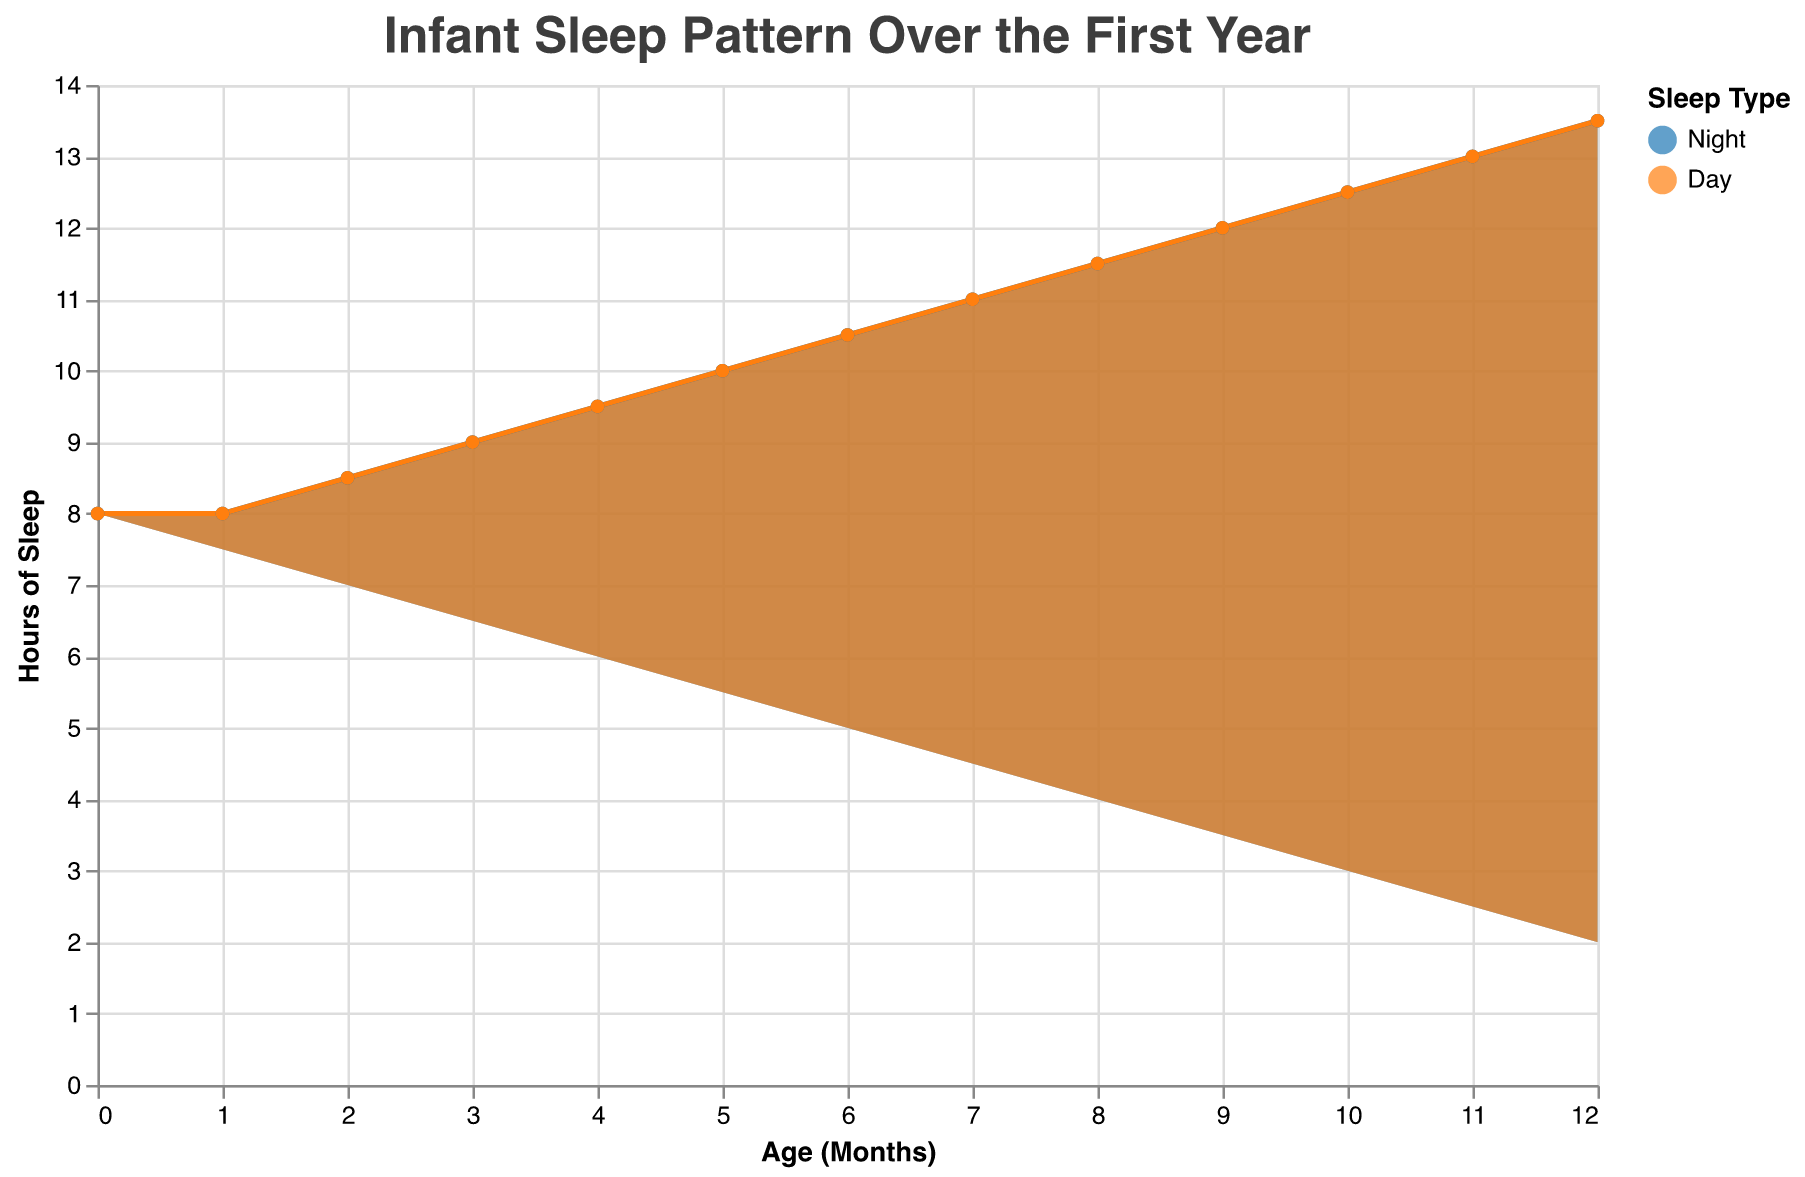What is the title of the chart? The title of the chart is typically placed at the top and is a description of the data represented in the figure. Here, it reads "Infant Sleep Pattern Over the First Year".
Answer: Infant Sleep Pattern Over the First Year How many hours of night sleep does a 6-month-old infant get? To find this information, look on the X-axis for 6 months and then follow it up to the corresponding value on the Y-axis for hours of sleep at night.
Answer: 10.5 What is the total number of hours of sleep for a 4-month-old infant? According to the data, the total hours of sleep per day across all months are constant at 15.5 hours.
Answer: 15.5 How does the amount of day sleep change from month 0 to month 12? The question requires you to look at the Hours of Sleep (Day) from Month 0 to Month 12. At month 0, it's 8 hours and it decreases incrementally to 2 hours by month 12.
Answer: Decreases from 8 to 2 hours Compare the amount of night sleep to day sleep at 9 months. Which is greater and by how much? At 9 months, the Hours of Sleep (Night) is 12 and Hours of Sleep (Day) is 3. Subtracting the day sleep from night sleep gives us the difference.
Answer: Night sleep is greater by 9 hours What trend can be observed in the night sleep pattern from month 0 to month 12? The pattern shows a gradual increase in night sleep. Starting from 8 hours at month 0, it steadily increases to 13.5 hours by month 12.
Answer: Gradual increase What is the difference in total sleep hours between month 0 and month 1? The data shows the total hours of sleep is 16 hours at month 0 and 15.5 hours at month 1. The difference is 16 - 15.5.
Answer: 0.5 hours At what month does an infant start sleeping more at night than during the day? Looking at the chart, you can observe that from month 5 onward, the night sleep hours exceed the day sleep hours.
Answer: 5 months What is the cumulative night sleep for the first 6 months? Summing the night sleep hours (8 + 8 + 8.5 + 9 + 9.5 + 10) gives us the total amount of night sleep over the first 6 months.
Answer: 53.5 hours During which month does the day sleep drop below 5 hours? From observing the chart, you can see that at month 7, the day sleep drops to 4.5 hours and continues to decrease.
Answer: 7 months 